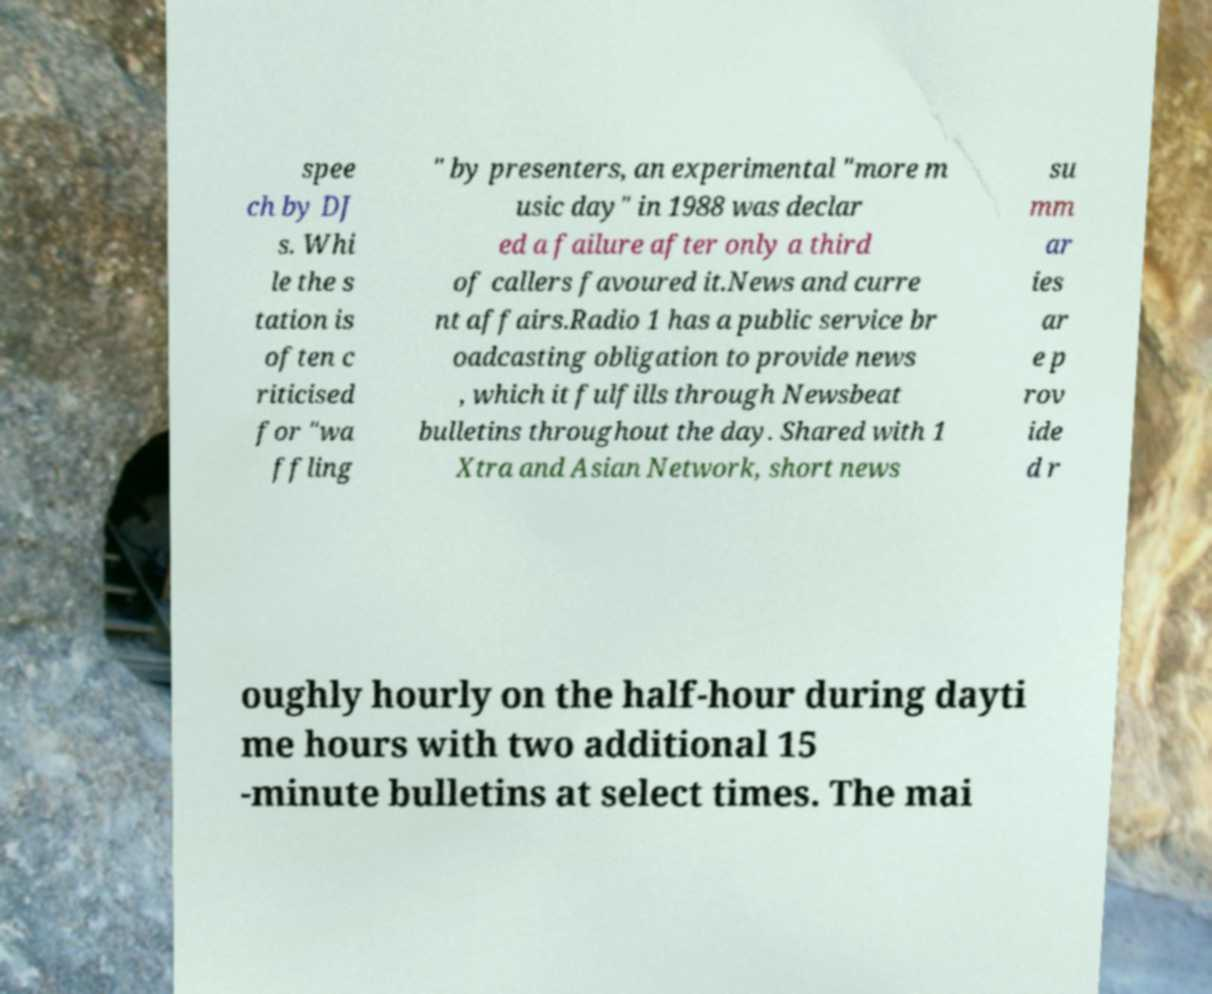What messages or text are displayed in this image? I need them in a readable, typed format. spee ch by DJ s. Whi le the s tation is often c riticised for "wa ffling " by presenters, an experimental "more m usic day" in 1988 was declar ed a failure after only a third of callers favoured it.News and curre nt affairs.Radio 1 has a public service br oadcasting obligation to provide news , which it fulfills through Newsbeat bulletins throughout the day. Shared with 1 Xtra and Asian Network, short news su mm ar ies ar e p rov ide d r oughly hourly on the half-hour during dayti me hours with two additional 15 -minute bulletins at select times. The mai 